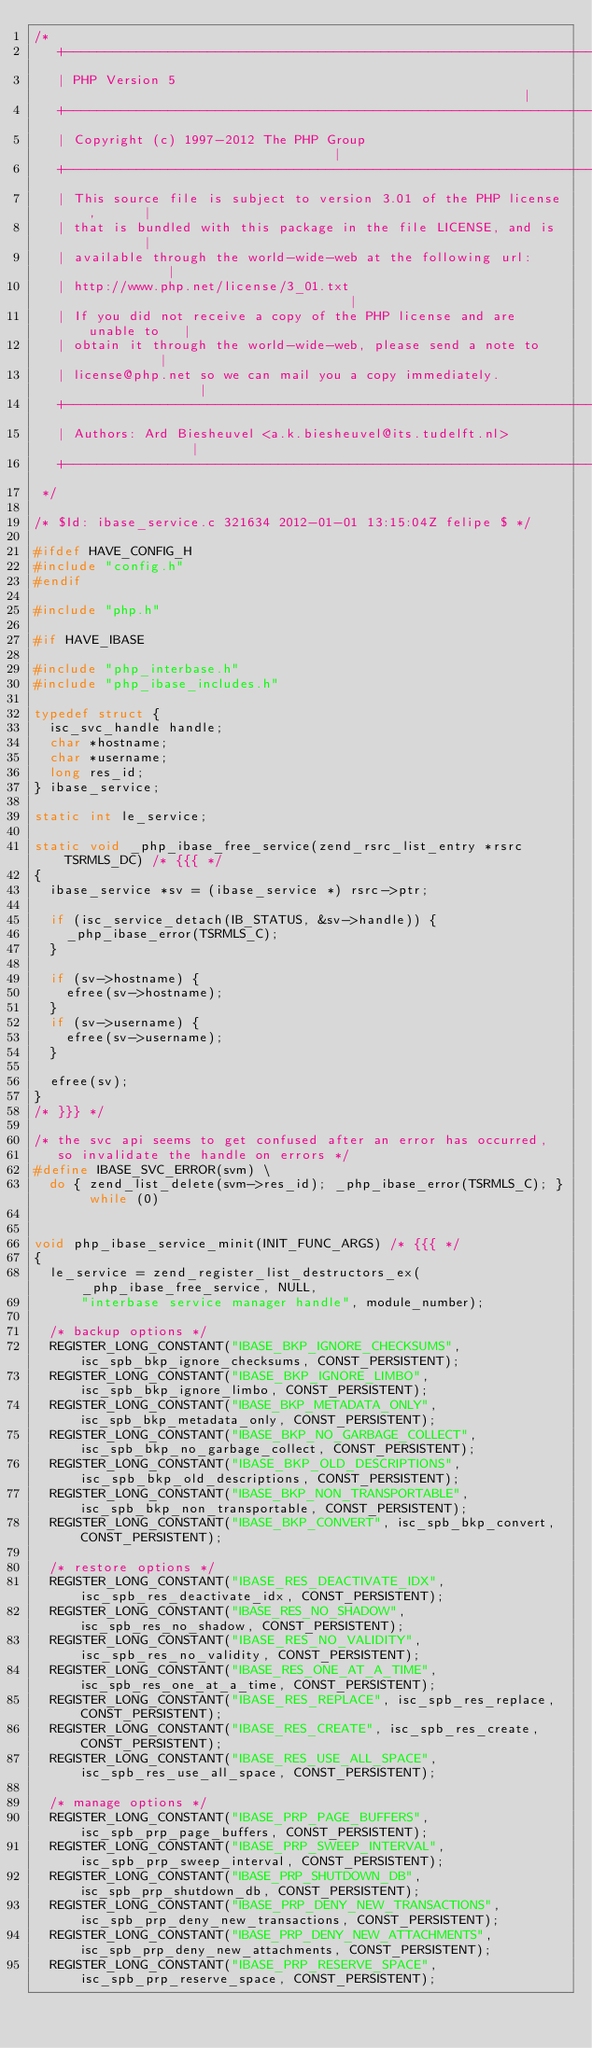Convert code to text. <code><loc_0><loc_0><loc_500><loc_500><_C_>/*
   +----------------------------------------------------------------------+
   | PHP Version 5                                                        |
   +----------------------------------------------------------------------+
   | Copyright (c) 1997-2012 The PHP Group                                |
   +----------------------------------------------------------------------+
   | This source file is subject to version 3.01 of the PHP license,      |
   | that is bundled with this package in the file LICENSE, and is        |
   | available through the world-wide-web at the following url:           |
   | http://www.php.net/license/3_01.txt                                  |
   | If you did not receive a copy of the PHP license and are unable to   |
   | obtain it through the world-wide-web, please send a note to          |
   | license@php.net so we can mail you a copy immediately.               |
   +----------------------------------------------------------------------+
   | Authors: Ard Biesheuvel <a.k.biesheuvel@its.tudelft.nl>              |
   +----------------------------------------------------------------------+
 */

/* $Id: ibase_service.c 321634 2012-01-01 13:15:04Z felipe $ */

#ifdef HAVE_CONFIG_H
#include "config.h"
#endif

#include "php.h"

#if HAVE_IBASE

#include "php_interbase.h"
#include "php_ibase_includes.h"

typedef struct {
	isc_svc_handle handle;
	char *hostname;
	char *username;
	long res_id;
} ibase_service;

static int le_service;

static void _php_ibase_free_service(zend_rsrc_list_entry *rsrc TSRMLS_DC) /* {{{ */
{
	ibase_service *sv = (ibase_service *) rsrc->ptr;

	if (isc_service_detach(IB_STATUS, &sv->handle)) {
		_php_ibase_error(TSRMLS_C);
	}

	if (sv->hostname) {
		efree(sv->hostname);
	}
	if (sv->username) {
		efree(sv->username);
	}

	efree(sv);
}
/* }}} */

/* the svc api seems to get confused after an error has occurred, 
   so invalidate the handle on errors */
#define IBASE_SVC_ERROR(svm) \
	do { zend_list_delete(svm->res_id); _php_ibase_error(TSRMLS_C); } while (0)
	

void php_ibase_service_minit(INIT_FUNC_ARGS) /* {{{ */
{
	le_service = zend_register_list_destructors_ex(_php_ibase_free_service, NULL, 
	    "interbase service manager handle", module_number);

	/* backup options */
	REGISTER_LONG_CONSTANT("IBASE_BKP_IGNORE_CHECKSUMS", isc_spb_bkp_ignore_checksums, CONST_PERSISTENT);
	REGISTER_LONG_CONSTANT("IBASE_BKP_IGNORE_LIMBO", isc_spb_bkp_ignore_limbo, CONST_PERSISTENT);
	REGISTER_LONG_CONSTANT("IBASE_BKP_METADATA_ONLY", isc_spb_bkp_metadata_only, CONST_PERSISTENT);
	REGISTER_LONG_CONSTANT("IBASE_BKP_NO_GARBAGE_COLLECT", isc_spb_bkp_no_garbage_collect, CONST_PERSISTENT);
	REGISTER_LONG_CONSTANT("IBASE_BKP_OLD_DESCRIPTIONS", isc_spb_bkp_old_descriptions, CONST_PERSISTENT);
	REGISTER_LONG_CONSTANT("IBASE_BKP_NON_TRANSPORTABLE", isc_spb_bkp_non_transportable, CONST_PERSISTENT);
	REGISTER_LONG_CONSTANT("IBASE_BKP_CONVERT", isc_spb_bkp_convert, CONST_PERSISTENT);

	/* restore options */
	REGISTER_LONG_CONSTANT("IBASE_RES_DEACTIVATE_IDX", isc_spb_res_deactivate_idx, CONST_PERSISTENT);
	REGISTER_LONG_CONSTANT("IBASE_RES_NO_SHADOW", isc_spb_res_no_shadow, CONST_PERSISTENT);
	REGISTER_LONG_CONSTANT("IBASE_RES_NO_VALIDITY", isc_spb_res_no_validity, CONST_PERSISTENT);
	REGISTER_LONG_CONSTANT("IBASE_RES_ONE_AT_A_TIME", isc_spb_res_one_at_a_time, CONST_PERSISTENT);
	REGISTER_LONG_CONSTANT("IBASE_RES_REPLACE", isc_spb_res_replace, CONST_PERSISTENT);
	REGISTER_LONG_CONSTANT("IBASE_RES_CREATE", isc_spb_res_create, CONST_PERSISTENT);
	REGISTER_LONG_CONSTANT("IBASE_RES_USE_ALL_SPACE", isc_spb_res_use_all_space, CONST_PERSISTENT);

	/* manage options */
	REGISTER_LONG_CONSTANT("IBASE_PRP_PAGE_BUFFERS", isc_spb_prp_page_buffers, CONST_PERSISTENT);
	REGISTER_LONG_CONSTANT("IBASE_PRP_SWEEP_INTERVAL", isc_spb_prp_sweep_interval, CONST_PERSISTENT);
	REGISTER_LONG_CONSTANT("IBASE_PRP_SHUTDOWN_DB", isc_spb_prp_shutdown_db, CONST_PERSISTENT);
	REGISTER_LONG_CONSTANT("IBASE_PRP_DENY_NEW_TRANSACTIONS", isc_spb_prp_deny_new_transactions, CONST_PERSISTENT);
	REGISTER_LONG_CONSTANT("IBASE_PRP_DENY_NEW_ATTACHMENTS", isc_spb_prp_deny_new_attachments, CONST_PERSISTENT);
	REGISTER_LONG_CONSTANT("IBASE_PRP_RESERVE_SPACE", isc_spb_prp_reserve_space, CONST_PERSISTENT);</code> 